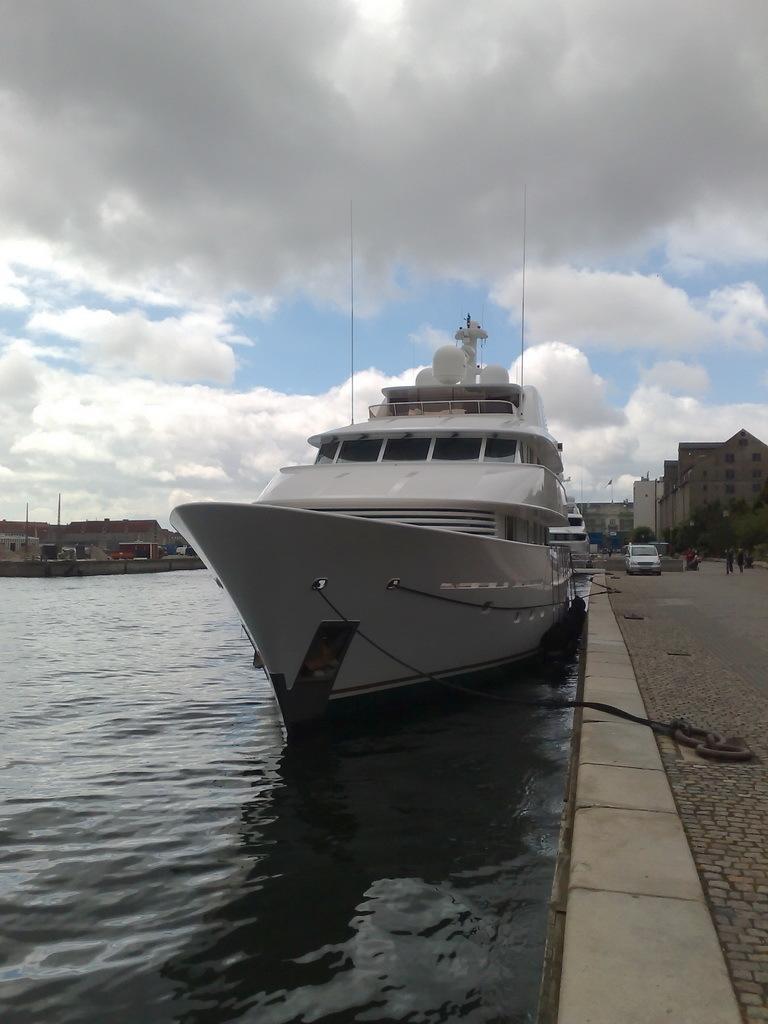In one or two sentences, can you explain what this image depicts? In this image, we can see a ship on the river and in the background, there are buildings, trees and some vehicles on the road. At the top, there are clouds in the sky. 